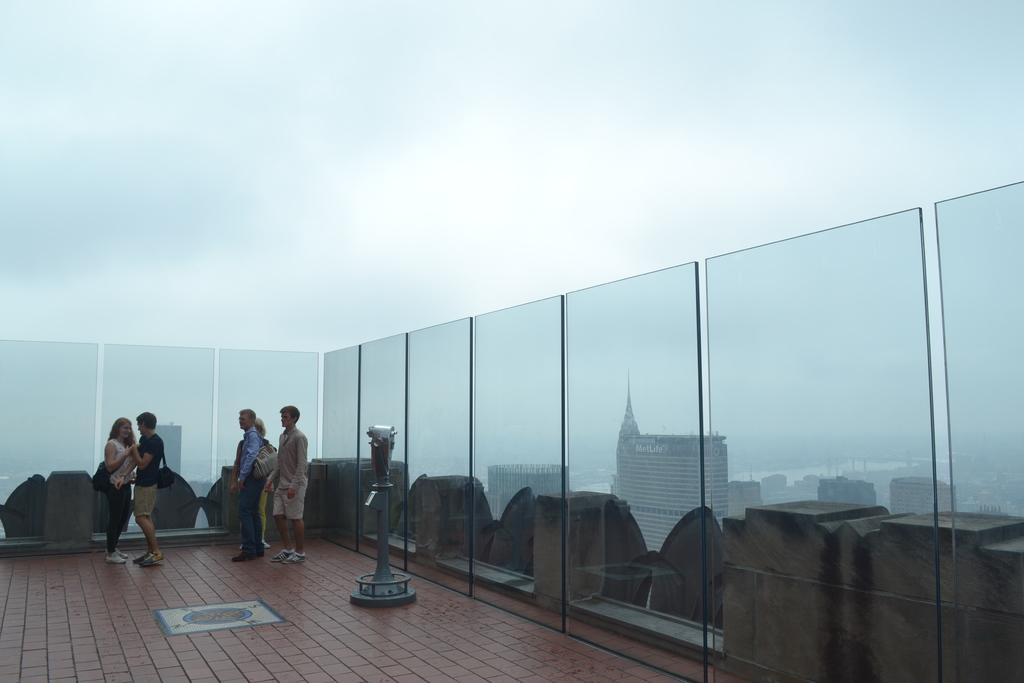What are the people doing on the rooftop? The facts do not specify what the people are doing on the rooftop. What object can be seen on the rooftop? There is an object on the rooftop, but the facts do not describe its nature. What type of walls are present on the rooftop? There are glass walls on the rooftop. What can be seen through the glass walls? Buildings are visible through the glass walls. What is visible in the sky? The sky is visible. What type of umbrella is being used by the people on the rooftop? There is no mention of an umbrella in the image, so it cannot be determined if one is being used. 